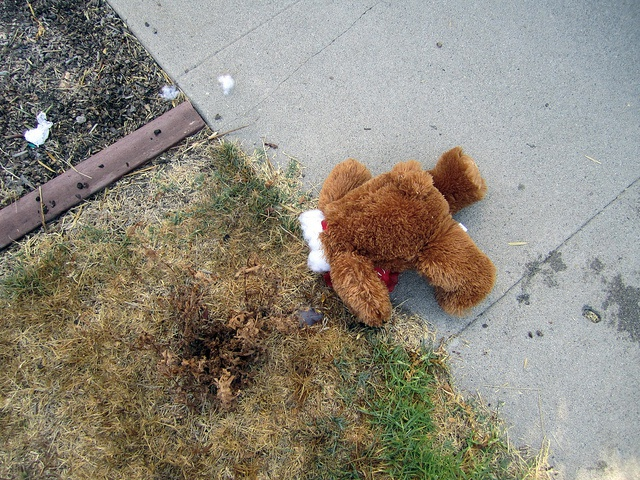Describe the objects in this image and their specific colors. I can see a teddy bear in black, maroon, brown, and gray tones in this image. 